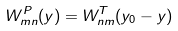<formula> <loc_0><loc_0><loc_500><loc_500>W _ { m n } ^ { P } ( y ) = W _ { n m } ^ { T } ( y _ { 0 } - y )</formula> 